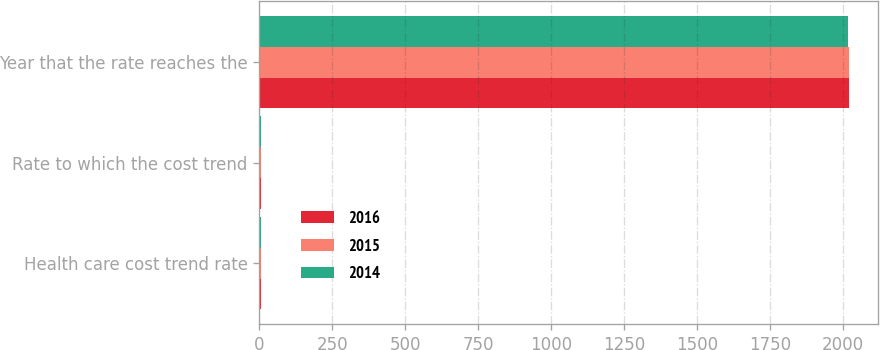Convert chart to OTSL. <chart><loc_0><loc_0><loc_500><loc_500><stacked_bar_chart><ecel><fcel>Health care cost trend rate<fcel>Rate to which the cost trend<fcel>Year that the rate reaches the<nl><fcel>2016<fcel>5.5<fcel>4.5<fcel>2020<nl><fcel>2015<fcel>5.5<fcel>4.5<fcel>2019<nl><fcel>2014<fcel>5.5<fcel>4.5<fcel>2018<nl></chart> 